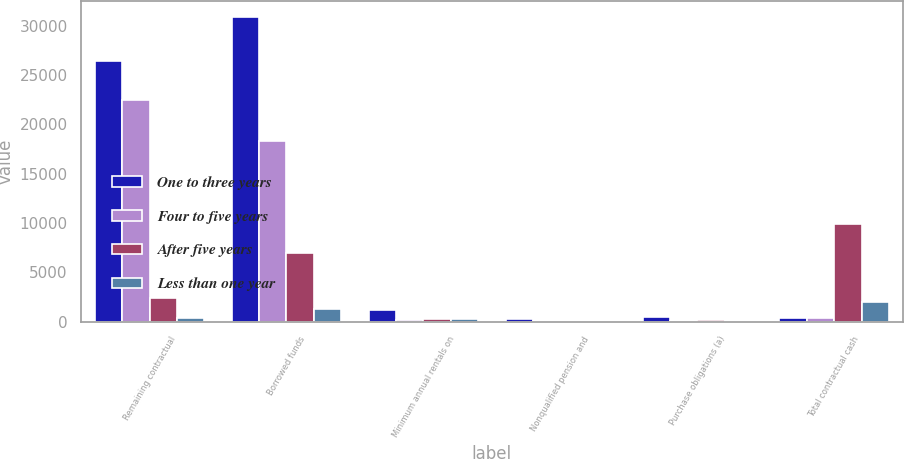Convert chart to OTSL. <chart><loc_0><loc_0><loc_500><loc_500><stacked_bar_chart><ecel><fcel>Remaining contractual<fcel>Borrowed funds<fcel>Minimum annual rentals on<fcel>Nonqualified pension and<fcel>Purchase obligations (a)<fcel>Total contractual cash<nl><fcel>One to three years<fcel>26402<fcel>30931<fcel>1239<fcel>314<fcel>441<fcel>395<nl><fcel>Four to five years<fcel>22500<fcel>18309<fcel>172<fcel>32<fcel>103<fcel>395<nl><fcel>After five years<fcel>2443<fcel>6967<fcel>296<fcel>67<fcel>179<fcel>9952<nl><fcel>Less than one year<fcel>349<fcel>1282<fcel>233<fcel>66<fcel>90<fcel>2020<nl></chart> 